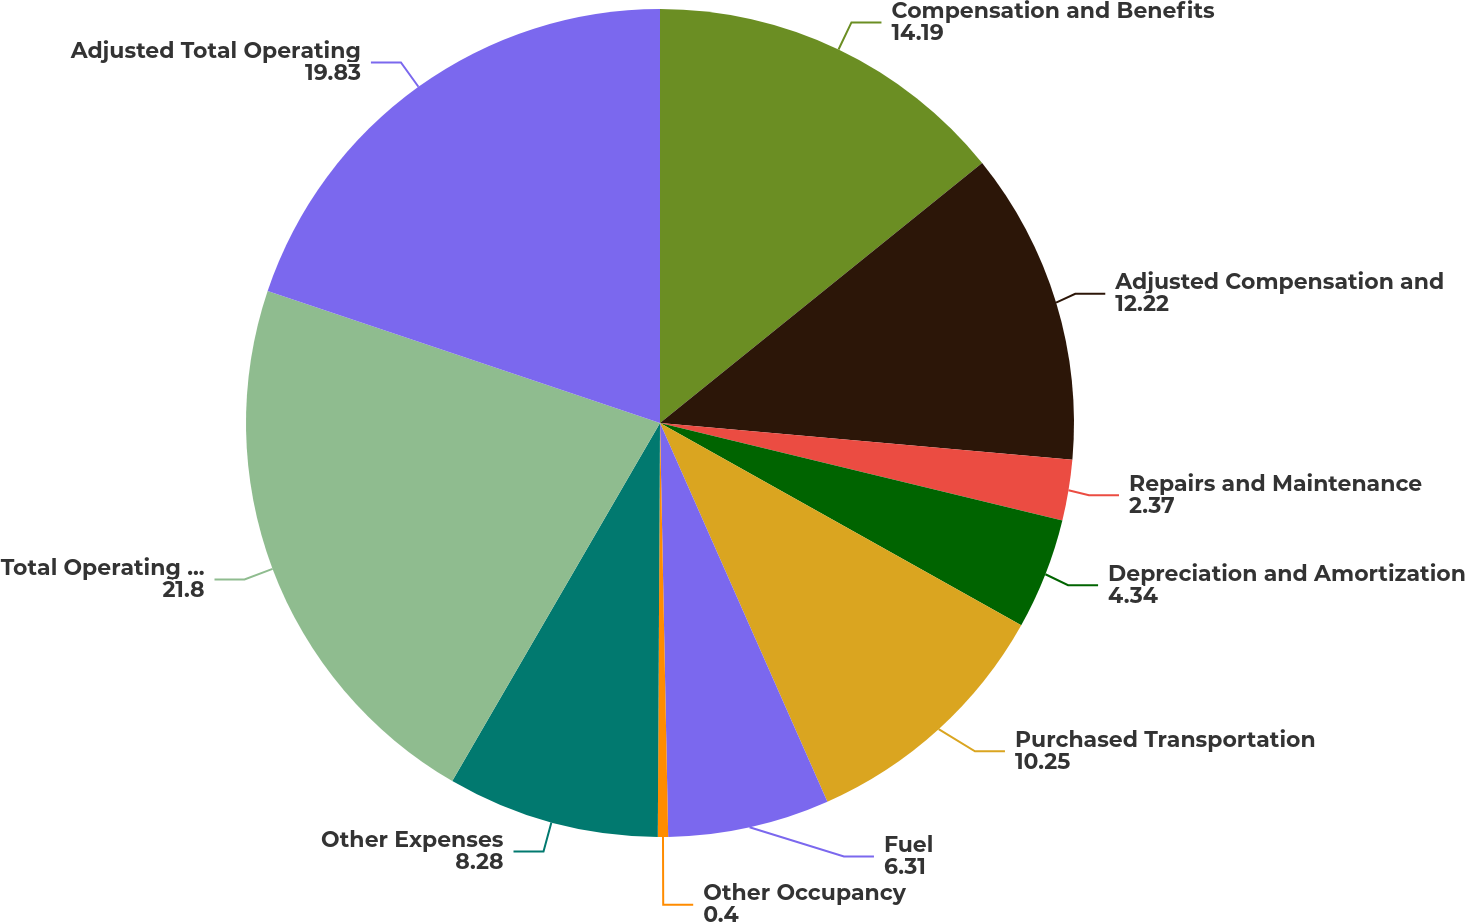Convert chart to OTSL. <chart><loc_0><loc_0><loc_500><loc_500><pie_chart><fcel>Compensation and Benefits<fcel>Adjusted Compensation and<fcel>Repairs and Maintenance<fcel>Depreciation and Amortization<fcel>Purchased Transportation<fcel>Fuel<fcel>Other Occupancy<fcel>Other Expenses<fcel>Total Operating Expenses<fcel>Adjusted Total Operating<nl><fcel>14.19%<fcel>12.22%<fcel>2.37%<fcel>4.34%<fcel>10.25%<fcel>6.31%<fcel>0.4%<fcel>8.28%<fcel>21.8%<fcel>19.83%<nl></chart> 